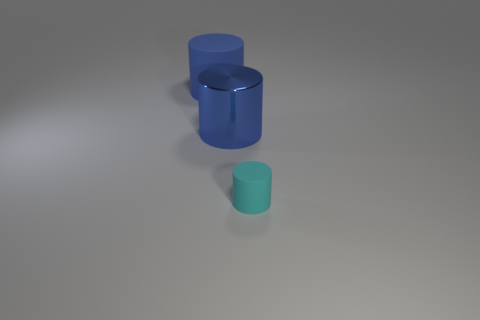Subtract all green spheres. How many blue cylinders are left? 2 Subtract all blue cylinders. How many cylinders are left? 1 Add 1 small yellow cylinders. How many objects exist? 4 Subtract all purple cylinders. Subtract all cyan spheres. How many cylinders are left? 3 Subtract all cyan cylinders. Subtract all big blue things. How many objects are left? 0 Add 2 large blue matte things. How many large blue matte things are left? 3 Add 3 large blue metal cylinders. How many large blue metal cylinders exist? 4 Subtract 0 green cylinders. How many objects are left? 3 